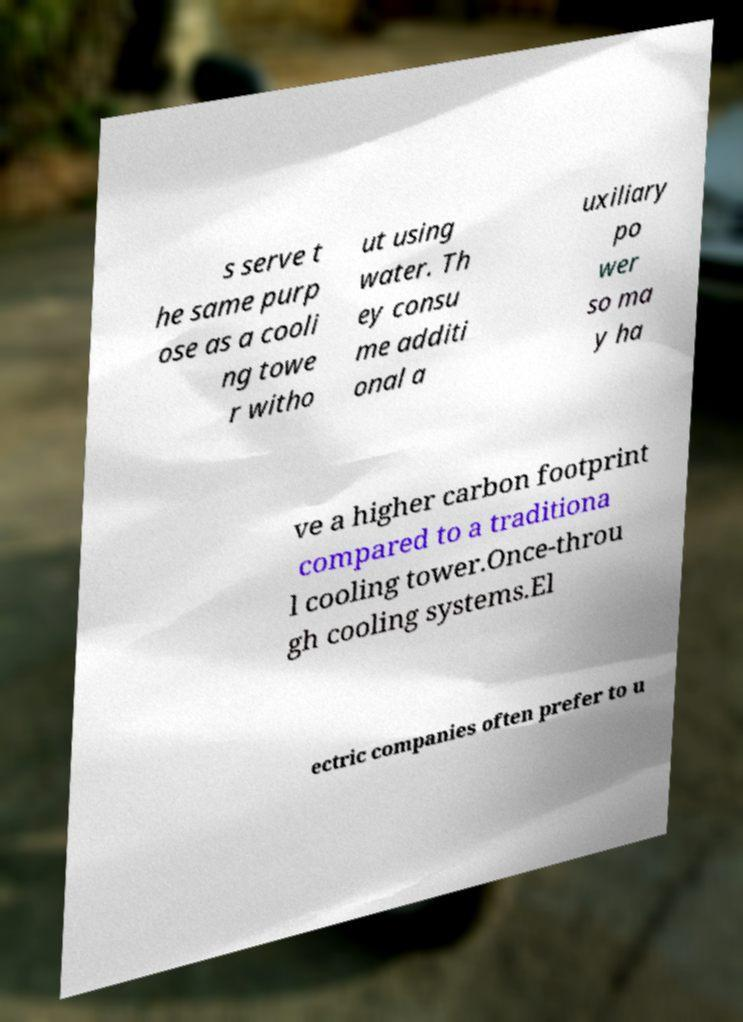What messages or text are displayed in this image? I need them in a readable, typed format. s serve t he same purp ose as a cooli ng towe r witho ut using water. Th ey consu me additi onal a uxiliary po wer so ma y ha ve a higher carbon footprint compared to a traditiona l cooling tower.Once-throu gh cooling systems.El ectric companies often prefer to u 